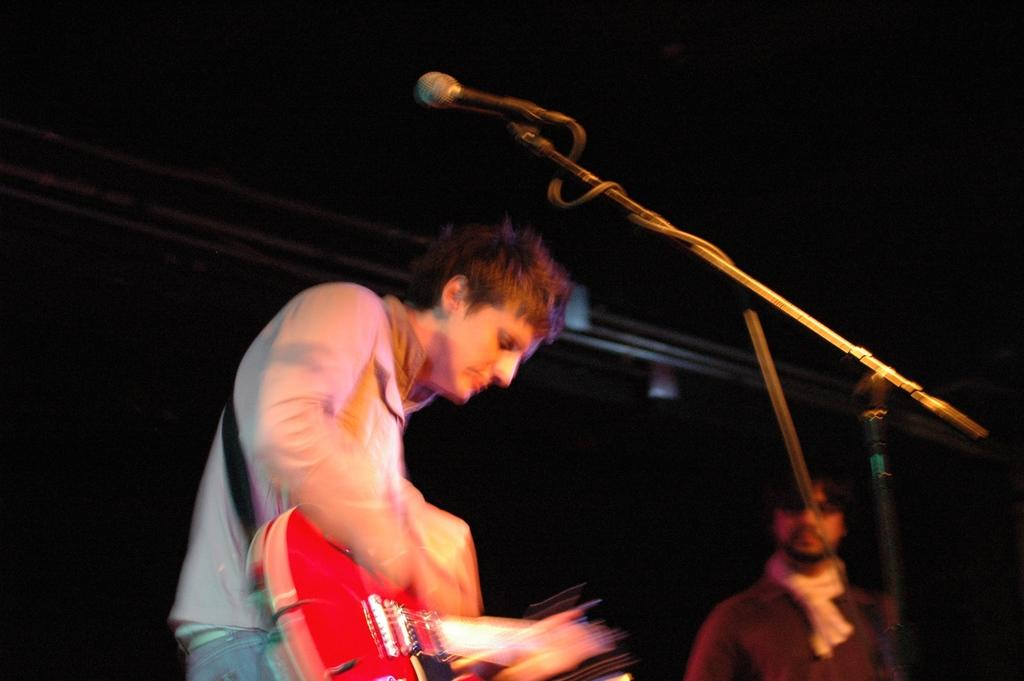How many people are in the image? There are two people in the image. What is one person doing in the image? One person is playing a guitar. Where is the guitar player located in the image? The guitar player is on the left side of the image. What object is present in the image that is commonly used for amplifying sound? There is a microphone in the image. What type of cap is the guitar player wearing in the image? There is no cap visible on the guitar player in the image. Can you see a field in the background of the image? There is no field present in the image; it features two people and a microphone. 